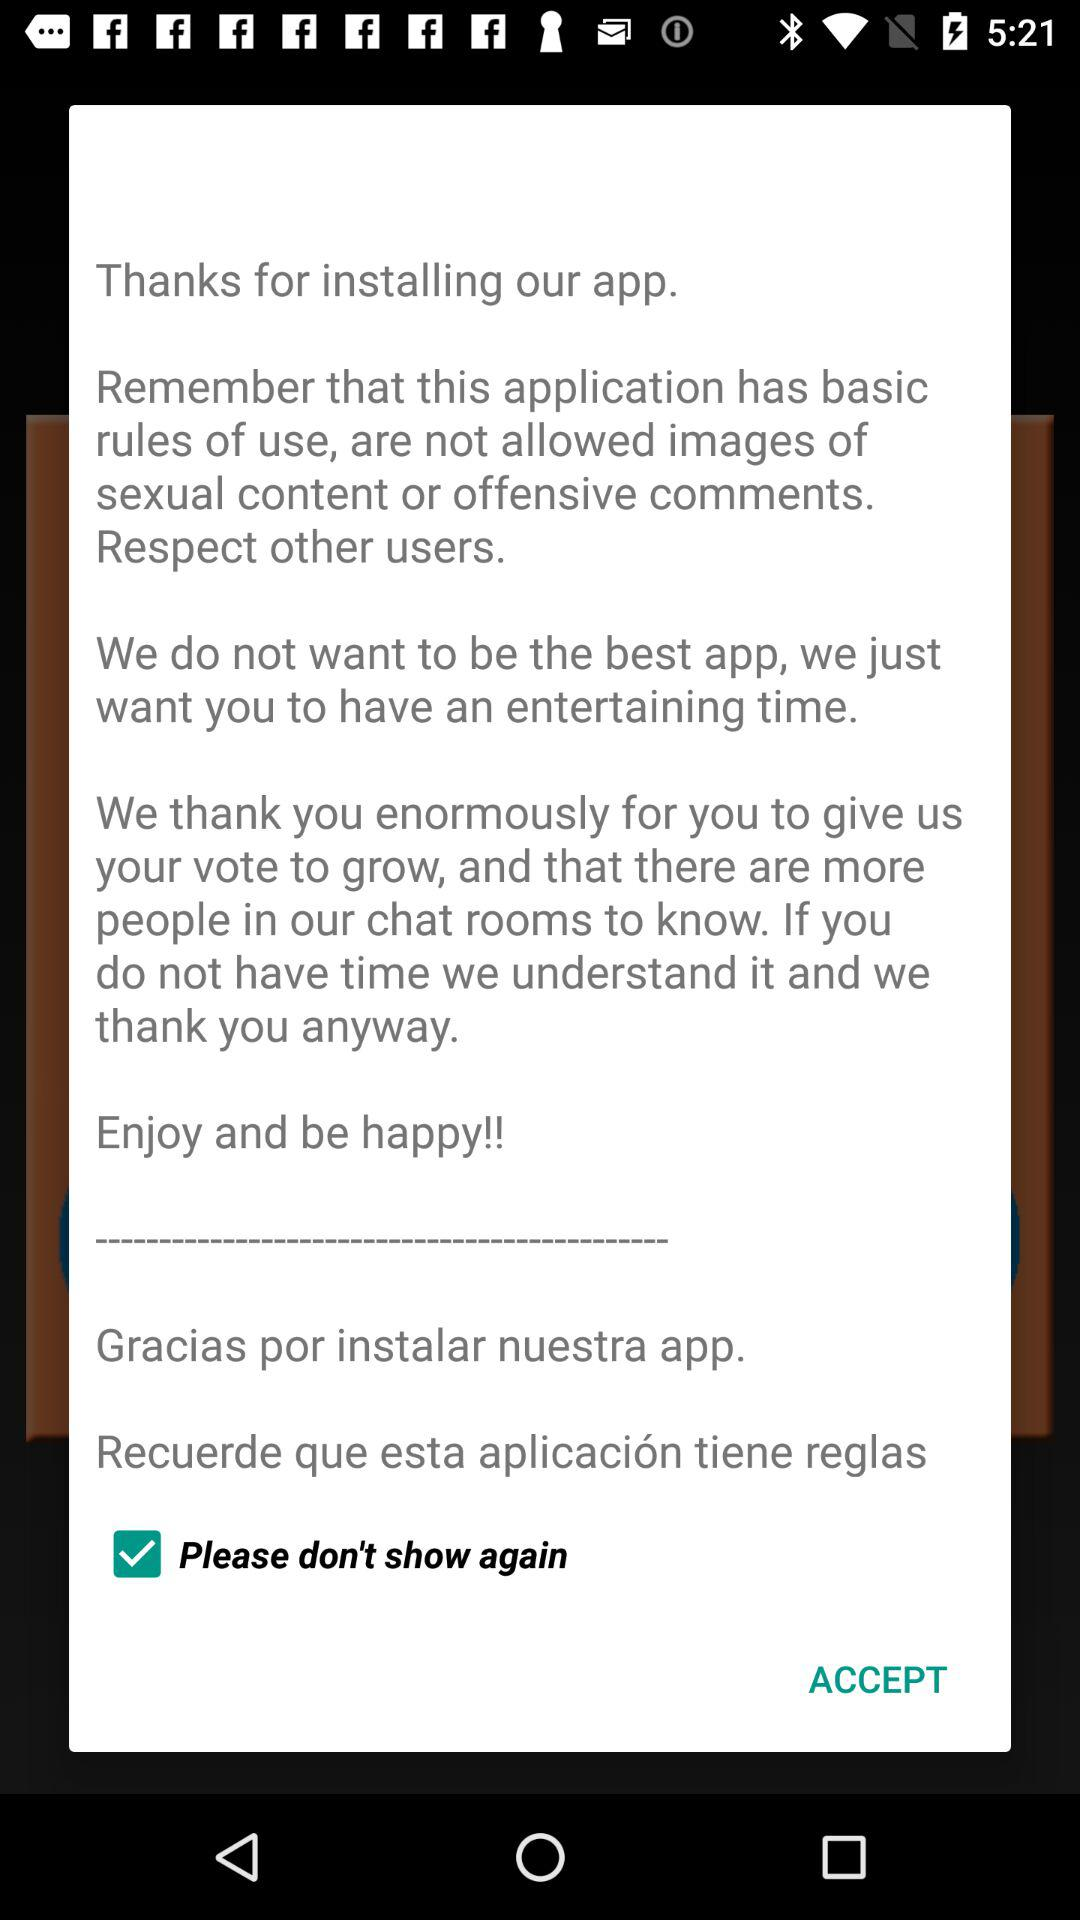What is the name of the application?
When the provided information is insufficient, respond with <no answer>. <no answer> 